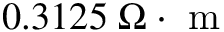<formula> <loc_0><loc_0><loc_500><loc_500>0 . 3 1 2 5 \, \Omega \cdot m</formula> 